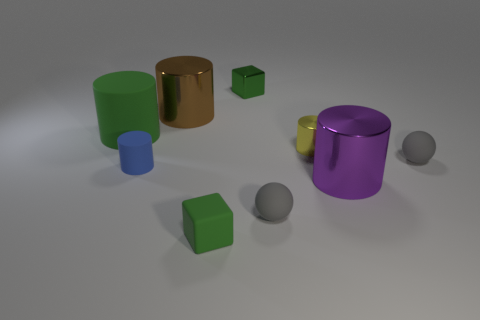Do the metal block and the large rubber thing have the same color?
Provide a succinct answer. Yes. There is a tiny cylinder on the right side of the metal thing to the left of the small green matte cube; what is it made of?
Offer a very short reply. Metal. What number of things are either big purple objects or big cylinders on the left side of the brown metallic object?
Provide a succinct answer. 2. The green object that is made of the same material as the big green cylinder is what size?
Your response must be concise. Small. Are there more small shiny cubes that are behind the purple metal cylinder than tiny cyan shiny spheres?
Make the answer very short. Yes. There is a matte object that is both in front of the small yellow shiny cylinder and to the left of the small rubber cube; how big is it?
Offer a terse response. Small. There is a small blue object that is the same shape as the big brown object; what material is it?
Provide a short and direct response. Rubber. Does the green thing that is to the left of the brown cylinder have the same size as the green rubber block?
Offer a very short reply. No. What color is the object that is both to the left of the big brown cylinder and in front of the large green rubber object?
Give a very brief answer. Blue. How many small yellow shiny objects are in front of the small green shiny block that is to the left of the yellow metal cylinder?
Your response must be concise. 1. 